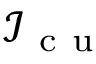<formula> <loc_0><loc_0><loc_500><loc_500>\mathcal { I } _ { c u }</formula> 